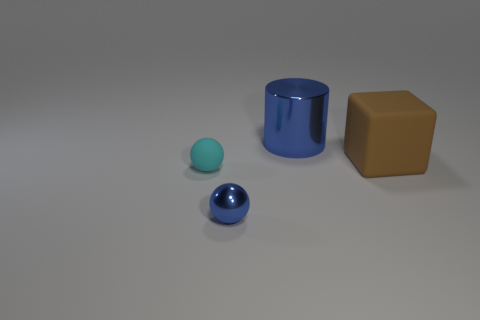What is the shape of the metal object in front of the cyan matte sphere?
Your answer should be very brief. Sphere. How many tiny cyan things are there?
Provide a short and direct response. 1. Do the blue cylinder and the tiny cyan object have the same material?
Offer a very short reply. No. Is the number of cyan objects that are right of the blue metallic cylinder greater than the number of large matte blocks?
Provide a short and direct response. No. What number of things are either small matte spheres or balls behind the tiny metallic ball?
Offer a very short reply. 1. Is the number of metallic balls behind the big block greater than the number of tiny matte balls that are behind the large blue cylinder?
Provide a short and direct response. No. What material is the big thing to the left of the matte thing on the right side of the small object to the right of the small cyan rubber object?
Ensure brevity in your answer.  Metal. There is a thing that is the same material as the brown block; what shape is it?
Your response must be concise. Sphere. There is a ball that is in front of the cyan thing; is there a large brown object behind it?
Your response must be concise. Yes. The shiny ball has what size?
Your response must be concise. Small. 